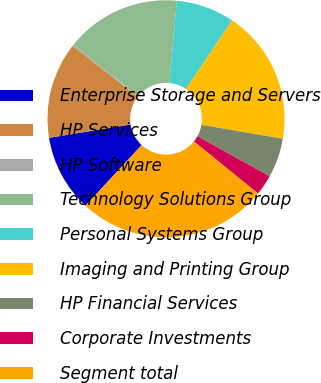Convert chart. <chart><loc_0><loc_0><loc_500><loc_500><pie_chart><fcel>Enterprise Storage and Servers<fcel>HP Services<fcel>HP Software<fcel>Technology Solutions Group<fcel>Personal Systems Group<fcel>Imaging and Printing Group<fcel>HP Financial Services<fcel>Corporate Investments<fcel>Segment total<nl><fcel>10.54%<fcel>13.12%<fcel>0.21%<fcel>15.7%<fcel>7.96%<fcel>18.28%<fcel>5.37%<fcel>2.79%<fcel>26.03%<nl></chart> 